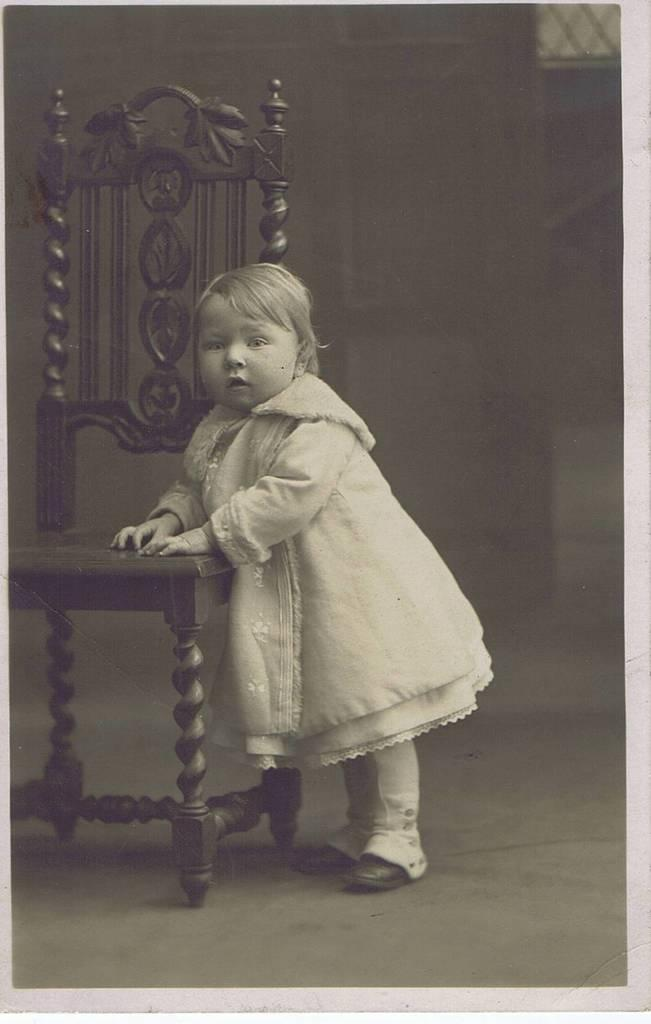Who is the main subject in the image? There is a little girl in the image. What is the little girl doing in the image? The little girl is standing in the image. What object is the little girl interacting with in the image? The little girl has her hands on a chair in the image. What type of guide is the little girl holding in the image? There is no guide present in the image; the little girl is simply standing with her hands on a chair. 